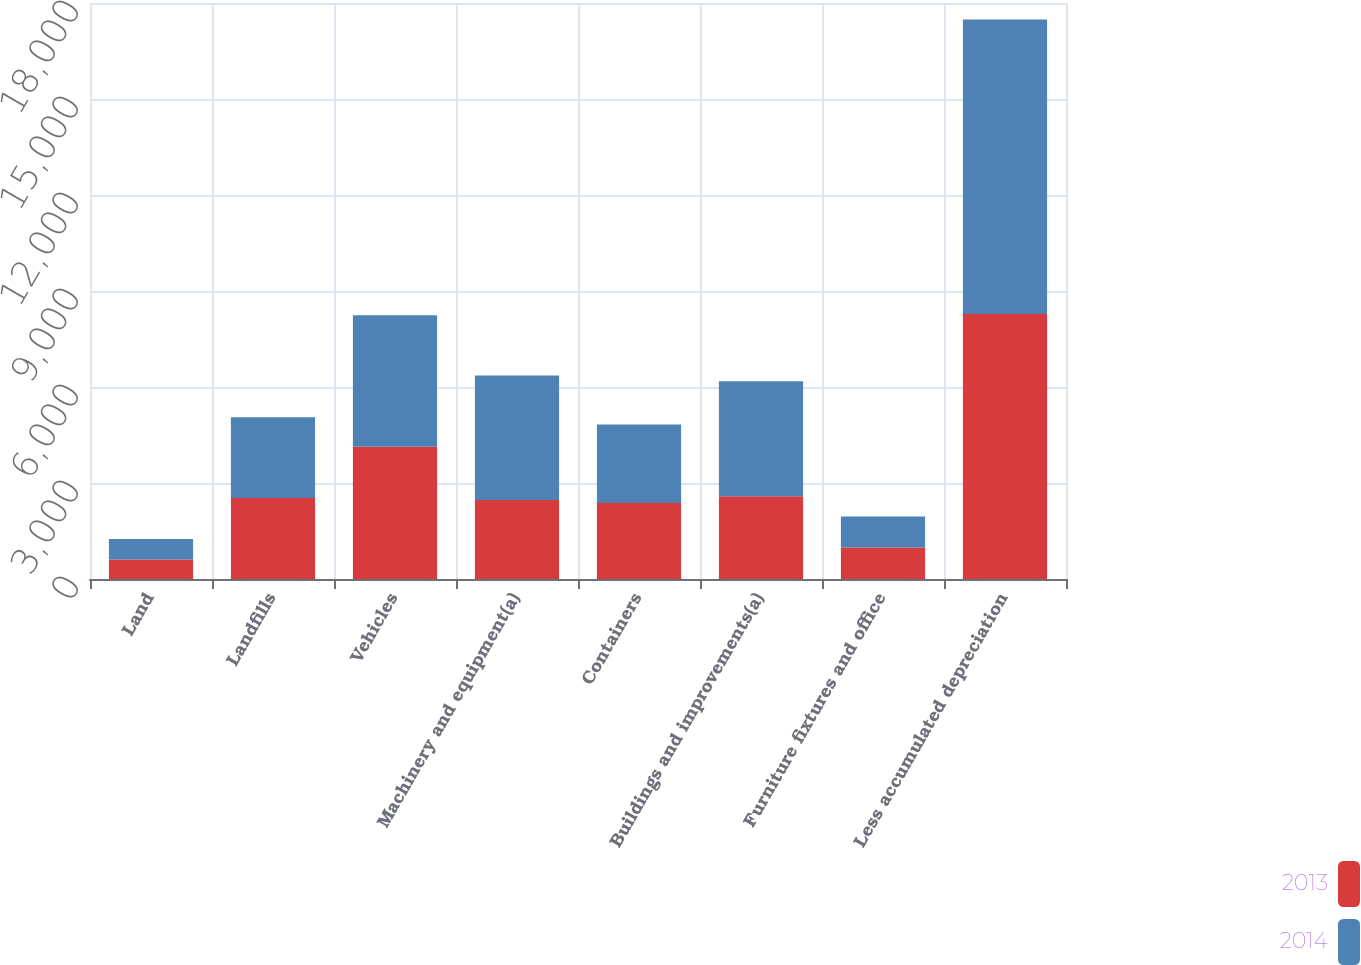<chart> <loc_0><loc_0><loc_500><loc_500><stacked_bar_chart><ecel><fcel>Land<fcel>Landfills<fcel>Vehicles<fcel>Machinery and equipment(a)<fcel>Containers<fcel>Buildings and improvements(a)<fcel>Furniture fixtures and office<fcel>Less accumulated depreciation<nl><fcel>2013<fcel>611<fcel>2529<fcel>4131<fcel>2470<fcel>2377<fcel>2588<fcel>985<fcel>8278<nl><fcel>2014<fcel>636<fcel>2529<fcel>4115<fcel>3888<fcel>2449<fcel>3594<fcel>969<fcel>9205<nl></chart> 